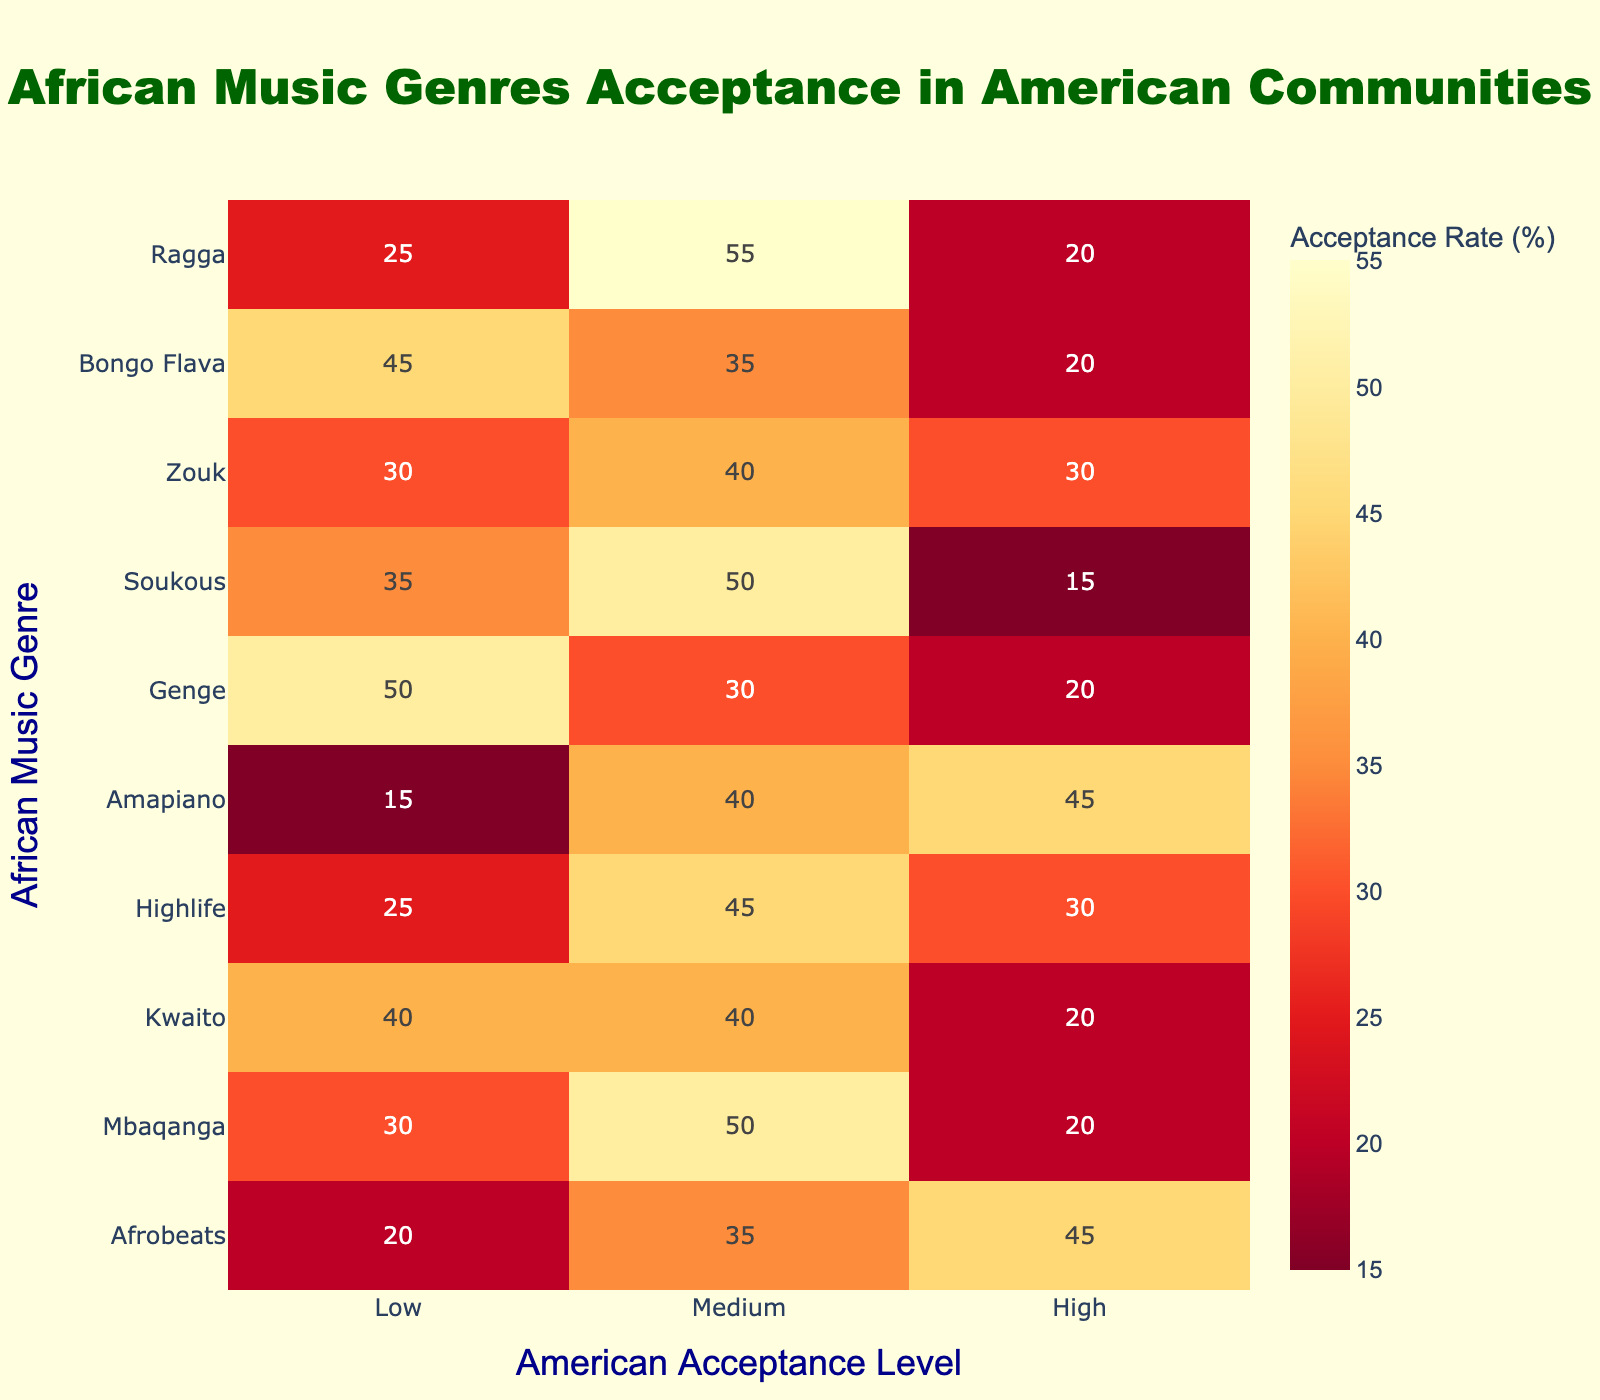What genre has the highest American acceptance rate? To determine this, look at the "High" acceptance column. Afrobeats has the highest value in that column at 45.
Answer: Afrobeats Which genre has the lowest acceptance rate in the "Low" category? In the "Low" category, Genge has the highest value of 50, making it the genre with the lowest acceptance rate considering that a higher number indicates a low acceptance.
Answer: Genge What is the average acceptance for Mbaqanga across all categories? The acceptance rates for Mbaqanga are 30, 50, and 20. To find the average, we sum these values: 30 + 50 + 20 = 100. Then divide by the number of categories (3): 100 / 3 = approximately 33.33.
Answer: 33.33 Does Amapiano have a higher acceptance rate in the "Medium" category than Highlife? Amapiano has a "Medium" value of 40 and Highlife has a "Medium" value of 45. Since 40 is less than 45, Amapiano does not have a higher acceptance rate than Highlife in the "Medium" category.
Answer: No Which genre combined has the highest acceptance rates in "Medium" and "High" categories? By adding the "Medium" and "High" acceptance rates for each genre, we find, for example: Afrobeats (35 + 45 = 80), Mbaqanga (50 + 20 = 70), Kwaito (40 + 20 = 60), Highlife (45 + 30 = 75), Amapiano (40 + 45 = 85), and so on. Amapiano has the highest combined value of 85.
Answer: Amapiano Is it true that Soukous has more representation in the "Low" category than Kwaito? Soukous has a "Low" rate of 35 and Kwaito has a "Low" rate of 40. Since 35 is less than 40, the statement is false.
Answer: No What is the difference between the "High" acceptance rate of Afrobeats and the "Low" acceptance rate of Genge? The "High" acceptance rate for Afrobeats is 45 and the "Low" acceptance rate for Genge is 50. The difference is calculated as 50 - 45 = 5.
Answer: 5 What percentage of genres have a "High" acceptance rate above 25? The genres with "High" values above 25 are Afrobeats (45), Highlife (30), and Amapiano (45). This is a total of 3 genres out of 10 total genres, giving a percentage of (3/10) * 100 = 30%.
Answer: 30% 